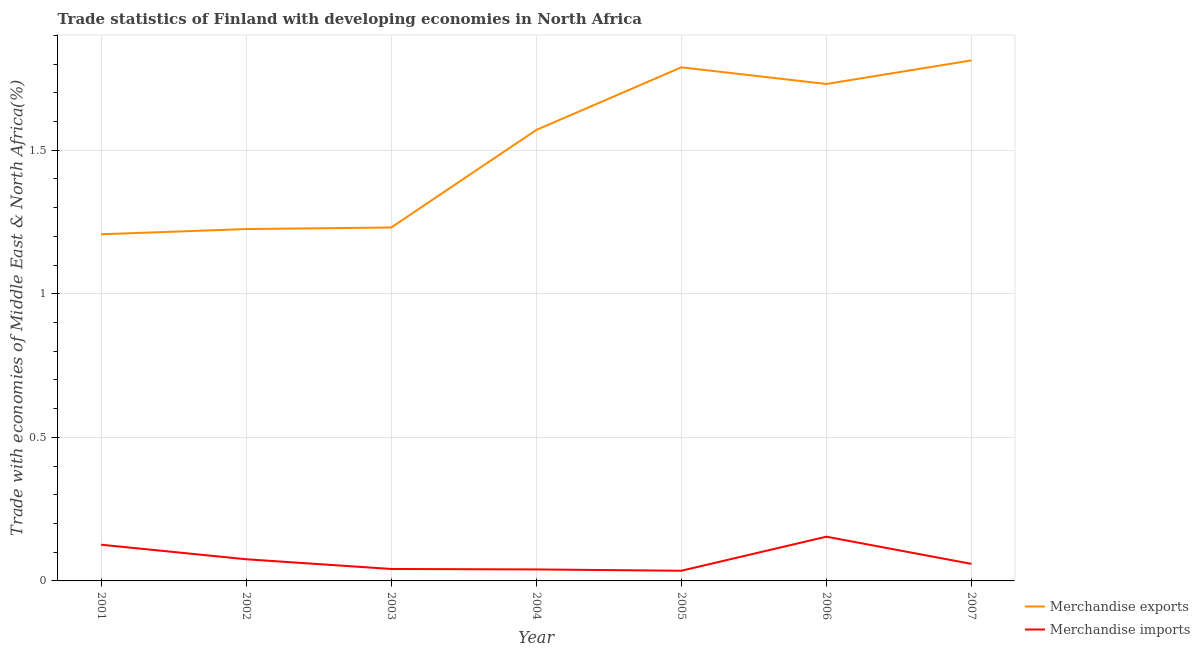Does the line corresponding to merchandise imports intersect with the line corresponding to merchandise exports?
Ensure brevity in your answer.  No. What is the merchandise imports in 2005?
Give a very brief answer. 0.04. Across all years, what is the maximum merchandise imports?
Offer a very short reply. 0.15. Across all years, what is the minimum merchandise exports?
Give a very brief answer. 1.21. In which year was the merchandise exports maximum?
Keep it short and to the point. 2007. What is the total merchandise imports in the graph?
Provide a short and direct response. 0.53. What is the difference between the merchandise imports in 2002 and that in 2006?
Offer a very short reply. -0.08. What is the difference between the merchandise imports in 2004 and the merchandise exports in 2006?
Keep it short and to the point. -1.69. What is the average merchandise exports per year?
Provide a succinct answer. 1.51. In the year 2003, what is the difference between the merchandise exports and merchandise imports?
Your answer should be compact. 1.19. What is the ratio of the merchandise imports in 2001 to that in 2007?
Provide a short and direct response. 2.12. Is the merchandise imports in 2002 less than that in 2005?
Give a very brief answer. No. Is the difference between the merchandise exports in 2003 and 2007 greater than the difference between the merchandise imports in 2003 and 2007?
Your response must be concise. No. What is the difference between the highest and the second highest merchandise exports?
Ensure brevity in your answer.  0.02. What is the difference between the highest and the lowest merchandise imports?
Ensure brevity in your answer.  0.12. In how many years, is the merchandise imports greater than the average merchandise imports taken over all years?
Make the answer very short. 2. How many years are there in the graph?
Offer a very short reply. 7. What is the difference between two consecutive major ticks on the Y-axis?
Give a very brief answer. 0.5. Are the values on the major ticks of Y-axis written in scientific E-notation?
Your answer should be compact. No. Where does the legend appear in the graph?
Make the answer very short. Bottom right. How many legend labels are there?
Ensure brevity in your answer.  2. How are the legend labels stacked?
Ensure brevity in your answer.  Vertical. What is the title of the graph?
Your answer should be very brief. Trade statistics of Finland with developing economies in North Africa. What is the label or title of the X-axis?
Your response must be concise. Year. What is the label or title of the Y-axis?
Your answer should be compact. Trade with economies of Middle East & North Africa(%). What is the Trade with economies of Middle East & North Africa(%) in Merchandise exports in 2001?
Offer a terse response. 1.21. What is the Trade with economies of Middle East & North Africa(%) of Merchandise imports in 2001?
Keep it short and to the point. 0.13. What is the Trade with economies of Middle East & North Africa(%) in Merchandise exports in 2002?
Keep it short and to the point. 1.23. What is the Trade with economies of Middle East & North Africa(%) of Merchandise imports in 2002?
Provide a succinct answer. 0.08. What is the Trade with economies of Middle East & North Africa(%) in Merchandise exports in 2003?
Your answer should be very brief. 1.23. What is the Trade with economies of Middle East & North Africa(%) in Merchandise imports in 2003?
Offer a terse response. 0.04. What is the Trade with economies of Middle East & North Africa(%) in Merchandise exports in 2004?
Provide a succinct answer. 1.57. What is the Trade with economies of Middle East & North Africa(%) in Merchandise imports in 2004?
Provide a short and direct response. 0.04. What is the Trade with economies of Middle East & North Africa(%) in Merchandise exports in 2005?
Your answer should be very brief. 1.79. What is the Trade with economies of Middle East & North Africa(%) in Merchandise imports in 2005?
Offer a very short reply. 0.04. What is the Trade with economies of Middle East & North Africa(%) in Merchandise exports in 2006?
Your answer should be compact. 1.73. What is the Trade with economies of Middle East & North Africa(%) of Merchandise imports in 2006?
Provide a short and direct response. 0.15. What is the Trade with economies of Middle East & North Africa(%) in Merchandise exports in 2007?
Provide a short and direct response. 1.81. What is the Trade with economies of Middle East & North Africa(%) in Merchandise imports in 2007?
Your response must be concise. 0.06. Across all years, what is the maximum Trade with economies of Middle East & North Africa(%) in Merchandise exports?
Ensure brevity in your answer.  1.81. Across all years, what is the maximum Trade with economies of Middle East & North Africa(%) of Merchandise imports?
Provide a succinct answer. 0.15. Across all years, what is the minimum Trade with economies of Middle East & North Africa(%) in Merchandise exports?
Offer a terse response. 1.21. Across all years, what is the minimum Trade with economies of Middle East & North Africa(%) in Merchandise imports?
Offer a terse response. 0.04. What is the total Trade with economies of Middle East & North Africa(%) in Merchandise exports in the graph?
Provide a short and direct response. 10.56. What is the total Trade with economies of Middle East & North Africa(%) of Merchandise imports in the graph?
Offer a very short reply. 0.53. What is the difference between the Trade with economies of Middle East & North Africa(%) of Merchandise exports in 2001 and that in 2002?
Offer a very short reply. -0.02. What is the difference between the Trade with economies of Middle East & North Africa(%) in Merchandise imports in 2001 and that in 2002?
Provide a succinct answer. 0.05. What is the difference between the Trade with economies of Middle East & North Africa(%) of Merchandise exports in 2001 and that in 2003?
Provide a short and direct response. -0.02. What is the difference between the Trade with economies of Middle East & North Africa(%) of Merchandise imports in 2001 and that in 2003?
Offer a terse response. 0.08. What is the difference between the Trade with economies of Middle East & North Africa(%) in Merchandise exports in 2001 and that in 2004?
Provide a succinct answer. -0.36. What is the difference between the Trade with economies of Middle East & North Africa(%) in Merchandise imports in 2001 and that in 2004?
Your answer should be very brief. 0.09. What is the difference between the Trade with economies of Middle East & North Africa(%) of Merchandise exports in 2001 and that in 2005?
Give a very brief answer. -0.58. What is the difference between the Trade with economies of Middle East & North Africa(%) in Merchandise imports in 2001 and that in 2005?
Make the answer very short. 0.09. What is the difference between the Trade with economies of Middle East & North Africa(%) of Merchandise exports in 2001 and that in 2006?
Provide a succinct answer. -0.52. What is the difference between the Trade with economies of Middle East & North Africa(%) of Merchandise imports in 2001 and that in 2006?
Provide a succinct answer. -0.03. What is the difference between the Trade with economies of Middle East & North Africa(%) in Merchandise exports in 2001 and that in 2007?
Your answer should be very brief. -0.61. What is the difference between the Trade with economies of Middle East & North Africa(%) of Merchandise imports in 2001 and that in 2007?
Make the answer very short. 0.07. What is the difference between the Trade with economies of Middle East & North Africa(%) in Merchandise exports in 2002 and that in 2003?
Ensure brevity in your answer.  -0.01. What is the difference between the Trade with economies of Middle East & North Africa(%) in Merchandise imports in 2002 and that in 2003?
Your answer should be compact. 0.03. What is the difference between the Trade with economies of Middle East & North Africa(%) of Merchandise exports in 2002 and that in 2004?
Provide a succinct answer. -0.34. What is the difference between the Trade with economies of Middle East & North Africa(%) in Merchandise imports in 2002 and that in 2004?
Provide a short and direct response. 0.04. What is the difference between the Trade with economies of Middle East & North Africa(%) in Merchandise exports in 2002 and that in 2005?
Give a very brief answer. -0.56. What is the difference between the Trade with economies of Middle East & North Africa(%) in Merchandise exports in 2002 and that in 2006?
Keep it short and to the point. -0.51. What is the difference between the Trade with economies of Middle East & North Africa(%) of Merchandise imports in 2002 and that in 2006?
Provide a short and direct response. -0.08. What is the difference between the Trade with economies of Middle East & North Africa(%) of Merchandise exports in 2002 and that in 2007?
Keep it short and to the point. -0.59. What is the difference between the Trade with economies of Middle East & North Africa(%) of Merchandise imports in 2002 and that in 2007?
Make the answer very short. 0.02. What is the difference between the Trade with economies of Middle East & North Africa(%) in Merchandise exports in 2003 and that in 2004?
Keep it short and to the point. -0.34. What is the difference between the Trade with economies of Middle East & North Africa(%) of Merchandise imports in 2003 and that in 2004?
Offer a very short reply. 0. What is the difference between the Trade with economies of Middle East & North Africa(%) of Merchandise exports in 2003 and that in 2005?
Provide a succinct answer. -0.56. What is the difference between the Trade with economies of Middle East & North Africa(%) of Merchandise imports in 2003 and that in 2005?
Your response must be concise. 0.01. What is the difference between the Trade with economies of Middle East & North Africa(%) in Merchandise exports in 2003 and that in 2006?
Offer a terse response. -0.5. What is the difference between the Trade with economies of Middle East & North Africa(%) of Merchandise imports in 2003 and that in 2006?
Your answer should be very brief. -0.11. What is the difference between the Trade with economies of Middle East & North Africa(%) of Merchandise exports in 2003 and that in 2007?
Provide a succinct answer. -0.58. What is the difference between the Trade with economies of Middle East & North Africa(%) in Merchandise imports in 2003 and that in 2007?
Provide a short and direct response. -0.02. What is the difference between the Trade with economies of Middle East & North Africa(%) in Merchandise exports in 2004 and that in 2005?
Provide a succinct answer. -0.22. What is the difference between the Trade with economies of Middle East & North Africa(%) of Merchandise imports in 2004 and that in 2005?
Ensure brevity in your answer.  0. What is the difference between the Trade with economies of Middle East & North Africa(%) in Merchandise exports in 2004 and that in 2006?
Provide a short and direct response. -0.16. What is the difference between the Trade with economies of Middle East & North Africa(%) in Merchandise imports in 2004 and that in 2006?
Offer a terse response. -0.11. What is the difference between the Trade with economies of Middle East & North Africa(%) of Merchandise exports in 2004 and that in 2007?
Offer a very short reply. -0.24. What is the difference between the Trade with economies of Middle East & North Africa(%) of Merchandise imports in 2004 and that in 2007?
Ensure brevity in your answer.  -0.02. What is the difference between the Trade with economies of Middle East & North Africa(%) of Merchandise exports in 2005 and that in 2006?
Provide a short and direct response. 0.06. What is the difference between the Trade with economies of Middle East & North Africa(%) in Merchandise imports in 2005 and that in 2006?
Your answer should be very brief. -0.12. What is the difference between the Trade with economies of Middle East & North Africa(%) of Merchandise exports in 2005 and that in 2007?
Make the answer very short. -0.02. What is the difference between the Trade with economies of Middle East & North Africa(%) in Merchandise imports in 2005 and that in 2007?
Your response must be concise. -0.02. What is the difference between the Trade with economies of Middle East & North Africa(%) in Merchandise exports in 2006 and that in 2007?
Keep it short and to the point. -0.08. What is the difference between the Trade with economies of Middle East & North Africa(%) of Merchandise imports in 2006 and that in 2007?
Provide a succinct answer. 0.09. What is the difference between the Trade with economies of Middle East & North Africa(%) in Merchandise exports in 2001 and the Trade with economies of Middle East & North Africa(%) in Merchandise imports in 2002?
Offer a terse response. 1.13. What is the difference between the Trade with economies of Middle East & North Africa(%) in Merchandise exports in 2001 and the Trade with economies of Middle East & North Africa(%) in Merchandise imports in 2003?
Make the answer very short. 1.17. What is the difference between the Trade with economies of Middle East & North Africa(%) in Merchandise exports in 2001 and the Trade with economies of Middle East & North Africa(%) in Merchandise imports in 2004?
Your response must be concise. 1.17. What is the difference between the Trade with economies of Middle East & North Africa(%) of Merchandise exports in 2001 and the Trade with economies of Middle East & North Africa(%) of Merchandise imports in 2005?
Offer a very short reply. 1.17. What is the difference between the Trade with economies of Middle East & North Africa(%) of Merchandise exports in 2001 and the Trade with economies of Middle East & North Africa(%) of Merchandise imports in 2006?
Offer a terse response. 1.05. What is the difference between the Trade with economies of Middle East & North Africa(%) in Merchandise exports in 2001 and the Trade with economies of Middle East & North Africa(%) in Merchandise imports in 2007?
Your answer should be compact. 1.15. What is the difference between the Trade with economies of Middle East & North Africa(%) in Merchandise exports in 2002 and the Trade with economies of Middle East & North Africa(%) in Merchandise imports in 2003?
Provide a short and direct response. 1.18. What is the difference between the Trade with economies of Middle East & North Africa(%) in Merchandise exports in 2002 and the Trade with economies of Middle East & North Africa(%) in Merchandise imports in 2004?
Keep it short and to the point. 1.19. What is the difference between the Trade with economies of Middle East & North Africa(%) in Merchandise exports in 2002 and the Trade with economies of Middle East & North Africa(%) in Merchandise imports in 2005?
Your answer should be very brief. 1.19. What is the difference between the Trade with economies of Middle East & North Africa(%) in Merchandise exports in 2002 and the Trade with economies of Middle East & North Africa(%) in Merchandise imports in 2006?
Ensure brevity in your answer.  1.07. What is the difference between the Trade with economies of Middle East & North Africa(%) in Merchandise exports in 2002 and the Trade with economies of Middle East & North Africa(%) in Merchandise imports in 2007?
Offer a very short reply. 1.17. What is the difference between the Trade with economies of Middle East & North Africa(%) in Merchandise exports in 2003 and the Trade with economies of Middle East & North Africa(%) in Merchandise imports in 2004?
Make the answer very short. 1.19. What is the difference between the Trade with economies of Middle East & North Africa(%) in Merchandise exports in 2003 and the Trade with economies of Middle East & North Africa(%) in Merchandise imports in 2005?
Provide a short and direct response. 1.2. What is the difference between the Trade with economies of Middle East & North Africa(%) in Merchandise exports in 2003 and the Trade with economies of Middle East & North Africa(%) in Merchandise imports in 2006?
Give a very brief answer. 1.08. What is the difference between the Trade with economies of Middle East & North Africa(%) in Merchandise exports in 2003 and the Trade with economies of Middle East & North Africa(%) in Merchandise imports in 2007?
Offer a very short reply. 1.17. What is the difference between the Trade with economies of Middle East & North Africa(%) of Merchandise exports in 2004 and the Trade with economies of Middle East & North Africa(%) of Merchandise imports in 2005?
Ensure brevity in your answer.  1.53. What is the difference between the Trade with economies of Middle East & North Africa(%) in Merchandise exports in 2004 and the Trade with economies of Middle East & North Africa(%) in Merchandise imports in 2006?
Provide a succinct answer. 1.42. What is the difference between the Trade with economies of Middle East & North Africa(%) in Merchandise exports in 2004 and the Trade with economies of Middle East & North Africa(%) in Merchandise imports in 2007?
Your answer should be very brief. 1.51. What is the difference between the Trade with economies of Middle East & North Africa(%) in Merchandise exports in 2005 and the Trade with economies of Middle East & North Africa(%) in Merchandise imports in 2006?
Keep it short and to the point. 1.63. What is the difference between the Trade with economies of Middle East & North Africa(%) of Merchandise exports in 2005 and the Trade with economies of Middle East & North Africa(%) of Merchandise imports in 2007?
Offer a terse response. 1.73. What is the difference between the Trade with economies of Middle East & North Africa(%) in Merchandise exports in 2006 and the Trade with economies of Middle East & North Africa(%) in Merchandise imports in 2007?
Provide a succinct answer. 1.67. What is the average Trade with economies of Middle East & North Africa(%) in Merchandise exports per year?
Give a very brief answer. 1.51. What is the average Trade with economies of Middle East & North Africa(%) in Merchandise imports per year?
Keep it short and to the point. 0.08. In the year 2001, what is the difference between the Trade with economies of Middle East & North Africa(%) in Merchandise exports and Trade with economies of Middle East & North Africa(%) in Merchandise imports?
Provide a succinct answer. 1.08. In the year 2002, what is the difference between the Trade with economies of Middle East & North Africa(%) in Merchandise exports and Trade with economies of Middle East & North Africa(%) in Merchandise imports?
Offer a very short reply. 1.15. In the year 2003, what is the difference between the Trade with economies of Middle East & North Africa(%) in Merchandise exports and Trade with economies of Middle East & North Africa(%) in Merchandise imports?
Provide a short and direct response. 1.19. In the year 2004, what is the difference between the Trade with economies of Middle East & North Africa(%) of Merchandise exports and Trade with economies of Middle East & North Africa(%) of Merchandise imports?
Offer a terse response. 1.53. In the year 2005, what is the difference between the Trade with economies of Middle East & North Africa(%) of Merchandise exports and Trade with economies of Middle East & North Africa(%) of Merchandise imports?
Offer a very short reply. 1.75. In the year 2006, what is the difference between the Trade with economies of Middle East & North Africa(%) of Merchandise exports and Trade with economies of Middle East & North Africa(%) of Merchandise imports?
Offer a very short reply. 1.58. In the year 2007, what is the difference between the Trade with economies of Middle East & North Africa(%) in Merchandise exports and Trade with economies of Middle East & North Africa(%) in Merchandise imports?
Provide a short and direct response. 1.75. What is the ratio of the Trade with economies of Middle East & North Africa(%) of Merchandise exports in 2001 to that in 2002?
Give a very brief answer. 0.99. What is the ratio of the Trade with economies of Middle East & North Africa(%) of Merchandise imports in 2001 to that in 2002?
Provide a short and direct response. 1.67. What is the ratio of the Trade with economies of Middle East & North Africa(%) of Merchandise exports in 2001 to that in 2003?
Make the answer very short. 0.98. What is the ratio of the Trade with economies of Middle East & North Africa(%) of Merchandise imports in 2001 to that in 2003?
Make the answer very short. 3.03. What is the ratio of the Trade with economies of Middle East & North Africa(%) in Merchandise exports in 2001 to that in 2004?
Your answer should be very brief. 0.77. What is the ratio of the Trade with economies of Middle East & North Africa(%) of Merchandise imports in 2001 to that in 2004?
Your response must be concise. 3.16. What is the ratio of the Trade with economies of Middle East & North Africa(%) in Merchandise exports in 2001 to that in 2005?
Keep it short and to the point. 0.67. What is the ratio of the Trade with economies of Middle East & North Africa(%) of Merchandise imports in 2001 to that in 2005?
Provide a succinct answer. 3.56. What is the ratio of the Trade with economies of Middle East & North Africa(%) in Merchandise exports in 2001 to that in 2006?
Keep it short and to the point. 0.7. What is the ratio of the Trade with economies of Middle East & North Africa(%) in Merchandise imports in 2001 to that in 2006?
Your answer should be compact. 0.82. What is the ratio of the Trade with economies of Middle East & North Africa(%) of Merchandise exports in 2001 to that in 2007?
Keep it short and to the point. 0.67. What is the ratio of the Trade with economies of Middle East & North Africa(%) of Merchandise imports in 2001 to that in 2007?
Make the answer very short. 2.12. What is the ratio of the Trade with economies of Middle East & North Africa(%) in Merchandise imports in 2002 to that in 2003?
Give a very brief answer. 1.81. What is the ratio of the Trade with economies of Middle East & North Africa(%) of Merchandise exports in 2002 to that in 2004?
Offer a very short reply. 0.78. What is the ratio of the Trade with economies of Middle East & North Africa(%) of Merchandise imports in 2002 to that in 2004?
Offer a very short reply. 1.89. What is the ratio of the Trade with economies of Middle East & North Africa(%) in Merchandise exports in 2002 to that in 2005?
Offer a terse response. 0.69. What is the ratio of the Trade with economies of Middle East & North Africa(%) in Merchandise imports in 2002 to that in 2005?
Provide a short and direct response. 2.13. What is the ratio of the Trade with economies of Middle East & North Africa(%) of Merchandise exports in 2002 to that in 2006?
Your response must be concise. 0.71. What is the ratio of the Trade with economies of Middle East & North Africa(%) in Merchandise imports in 2002 to that in 2006?
Your response must be concise. 0.49. What is the ratio of the Trade with economies of Middle East & North Africa(%) in Merchandise exports in 2002 to that in 2007?
Make the answer very short. 0.68. What is the ratio of the Trade with economies of Middle East & North Africa(%) in Merchandise imports in 2002 to that in 2007?
Keep it short and to the point. 1.27. What is the ratio of the Trade with economies of Middle East & North Africa(%) in Merchandise exports in 2003 to that in 2004?
Make the answer very short. 0.78. What is the ratio of the Trade with economies of Middle East & North Africa(%) in Merchandise imports in 2003 to that in 2004?
Give a very brief answer. 1.04. What is the ratio of the Trade with economies of Middle East & North Africa(%) in Merchandise exports in 2003 to that in 2005?
Keep it short and to the point. 0.69. What is the ratio of the Trade with economies of Middle East & North Africa(%) in Merchandise imports in 2003 to that in 2005?
Your response must be concise. 1.17. What is the ratio of the Trade with economies of Middle East & North Africa(%) in Merchandise exports in 2003 to that in 2006?
Your answer should be very brief. 0.71. What is the ratio of the Trade with economies of Middle East & North Africa(%) of Merchandise imports in 2003 to that in 2006?
Give a very brief answer. 0.27. What is the ratio of the Trade with economies of Middle East & North Africa(%) in Merchandise exports in 2003 to that in 2007?
Make the answer very short. 0.68. What is the ratio of the Trade with economies of Middle East & North Africa(%) of Merchandise imports in 2003 to that in 2007?
Ensure brevity in your answer.  0.7. What is the ratio of the Trade with economies of Middle East & North Africa(%) in Merchandise exports in 2004 to that in 2005?
Provide a succinct answer. 0.88. What is the ratio of the Trade with economies of Middle East & North Africa(%) in Merchandise imports in 2004 to that in 2005?
Give a very brief answer. 1.13. What is the ratio of the Trade with economies of Middle East & North Africa(%) in Merchandise exports in 2004 to that in 2006?
Ensure brevity in your answer.  0.91. What is the ratio of the Trade with economies of Middle East & North Africa(%) in Merchandise imports in 2004 to that in 2006?
Your answer should be compact. 0.26. What is the ratio of the Trade with economies of Middle East & North Africa(%) of Merchandise exports in 2004 to that in 2007?
Your response must be concise. 0.87. What is the ratio of the Trade with economies of Middle East & North Africa(%) of Merchandise imports in 2004 to that in 2007?
Your answer should be compact. 0.67. What is the ratio of the Trade with economies of Middle East & North Africa(%) of Merchandise exports in 2005 to that in 2006?
Provide a short and direct response. 1.03. What is the ratio of the Trade with economies of Middle East & North Africa(%) in Merchandise imports in 2005 to that in 2006?
Offer a very short reply. 0.23. What is the ratio of the Trade with economies of Middle East & North Africa(%) of Merchandise exports in 2005 to that in 2007?
Your response must be concise. 0.99. What is the ratio of the Trade with economies of Middle East & North Africa(%) of Merchandise imports in 2005 to that in 2007?
Make the answer very short. 0.6. What is the ratio of the Trade with economies of Middle East & North Africa(%) in Merchandise exports in 2006 to that in 2007?
Keep it short and to the point. 0.95. What is the ratio of the Trade with economies of Middle East & North Africa(%) in Merchandise imports in 2006 to that in 2007?
Offer a terse response. 2.59. What is the difference between the highest and the second highest Trade with economies of Middle East & North Africa(%) of Merchandise exports?
Offer a very short reply. 0.02. What is the difference between the highest and the second highest Trade with economies of Middle East & North Africa(%) of Merchandise imports?
Ensure brevity in your answer.  0.03. What is the difference between the highest and the lowest Trade with economies of Middle East & North Africa(%) in Merchandise exports?
Offer a terse response. 0.61. What is the difference between the highest and the lowest Trade with economies of Middle East & North Africa(%) of Merchandise imports?
Give a very brief answer. 0.12. 